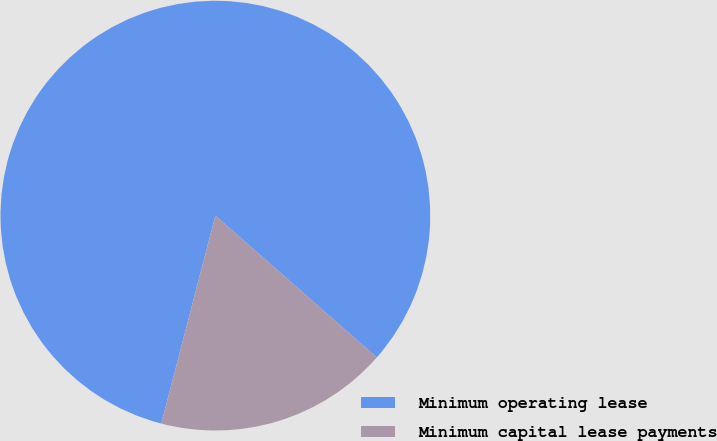Convert chart. <chart><loc_0><loc_0><loc_500><loc_500><pie_chart><fcel>Minimum operating lease<fcel>Minimum capital lease payments<nl><fcel>82.42%<fcel>17.58%<nl></chart> 